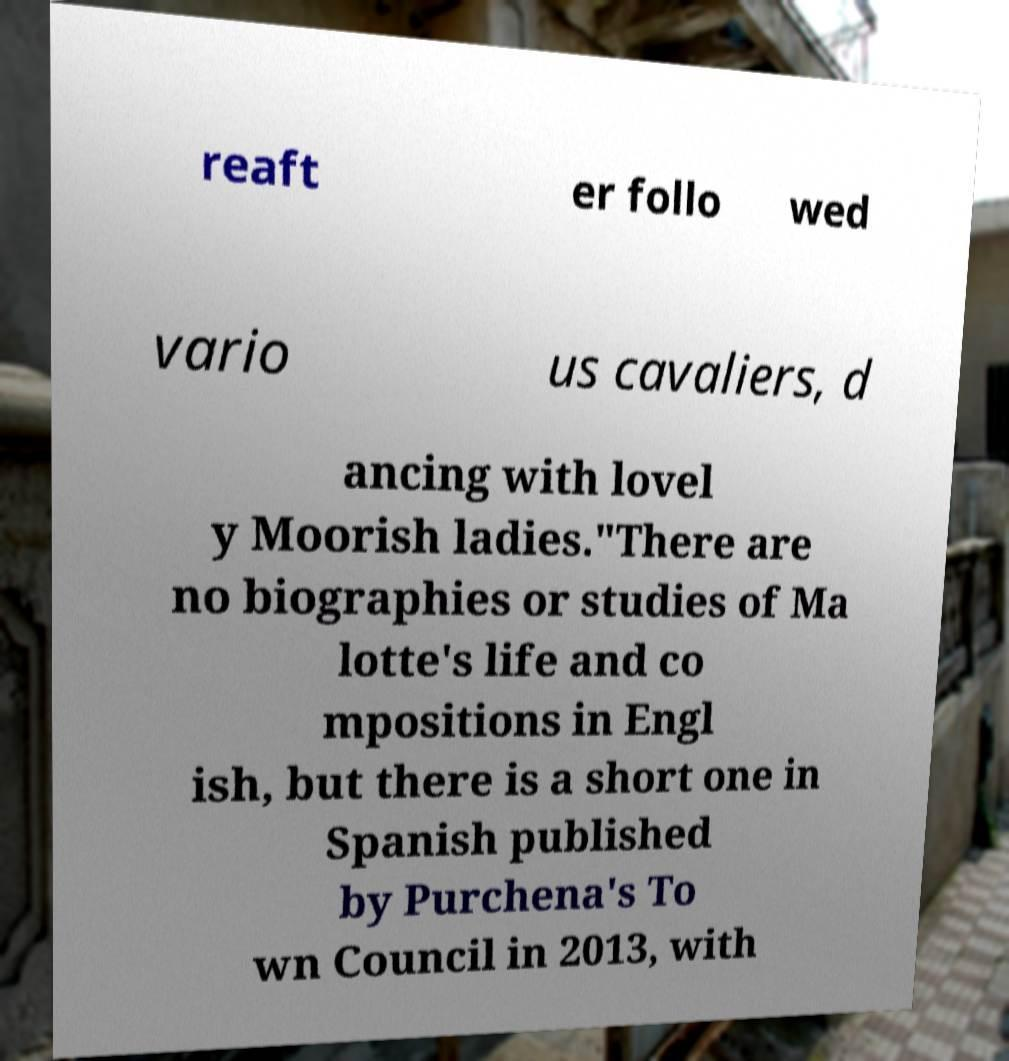Please read and relay the text visible in this image. What does it say? reaft er follo wed vario us cavaliers, d ancing with lovel y Moorish ladies."There are no biographies or studies of Ma lotte's life and co mpositions in Engl ish, but there is a short one in Spanish published by Purchena's To wn Council in 2013, with 